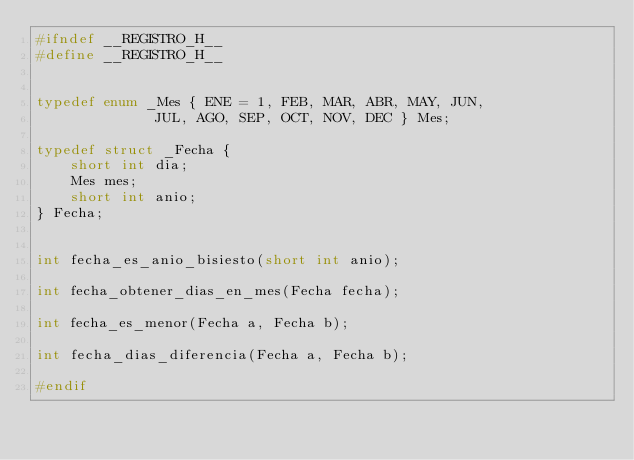<code> <loc_0><loc_0><loc_500><loc_500><_C_>#ifndef __REGISTRO_H__
#define __REGISTRO_H__


typedef enum _Mes { ENE = 1, FEB, MAR, ABR, MAY, JUN,
              JUL, AGO, SEP, OCT, NOV, DEC } Mes;
              
typedef struct _Fecha {
    short int dia;
    Mes mes;
    short int anio;
} Fecha;


int fecha_es_anio_bisiesto(short int anio);

int fecha_obtener_dias_en_mes(Fecha fecha);

int fecha_es_menor(Fecha a, Fecha b);

int fecha_dias_diferencia(Fecha a, Fecha b);

#endif
</code> 